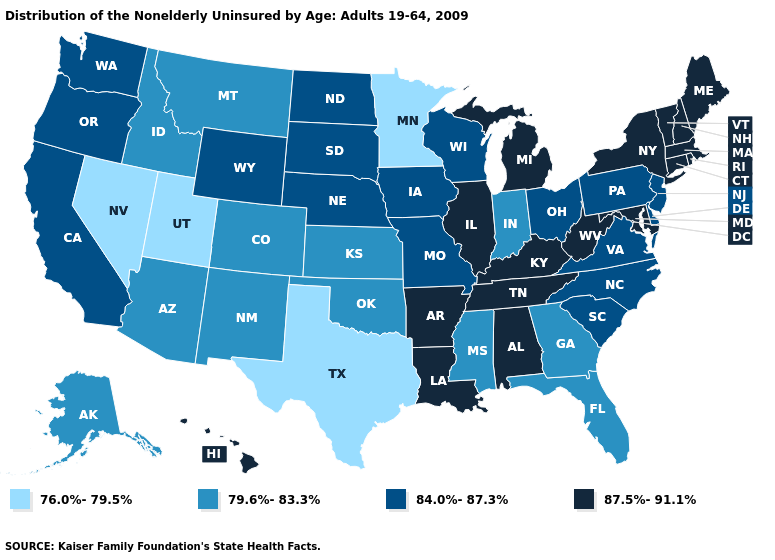Does South Dakota have the lowest value in the MidWest?
Answer briefly. No. What is the lowest value in the USA?
Be succinct. 76.0%-79.5%. What is the value of California?
Be succinct. 84.0%-87.3%. Name the states that have a value in the range 76.0%-79.5%?
Give a very brief answer. Minnesota, Nevada, Texas, Utah. What is the value of New Jersey?
Answer briefly. 84.0%-87.3%. Name the states that have a value in the range 79.6%-83.3%?
Quick response, please. Alaska, Arizona, Colorado, Florida, Georgia, Idaho, Indiana, Kansas, Mississippi, Montana, New Mexico, Oklahoma. Does Delaware have a higher value than Utah?
Keep it brief. Yes. Name the states that have a value in the range 79.6%-83.3%?
Short answer required. Alaska, Arizona, Colorado, Florida, Georgia, Idaho, Indiana, Kansas, Mississippi, Montana, New Mexico, Oklahoma. What is the value of Louisiana?
Short answer required. 87.5%-91.1%. What is the value of New Jersey?
Quick response, please. 84.0%-87.3%. Does the map have missing data?
Concise answer only. No. Name the states that have a value in the range 79.6%-83.3%?
Keep it brief. Alaska, Arizona, Colorado, Florida, Georgia, Idaho, Indiana, Kansas, Mississippi, Montana, New Mexico, Oklahoma. What is the value of South Dakota?
Give a very brief answer. 84.0%-87.3%. Does Texas have the same value as Nevada?
Concise answer only. Yes. Does Oklahoma have the same value as Kansas?
Answer briefly. Yes. 